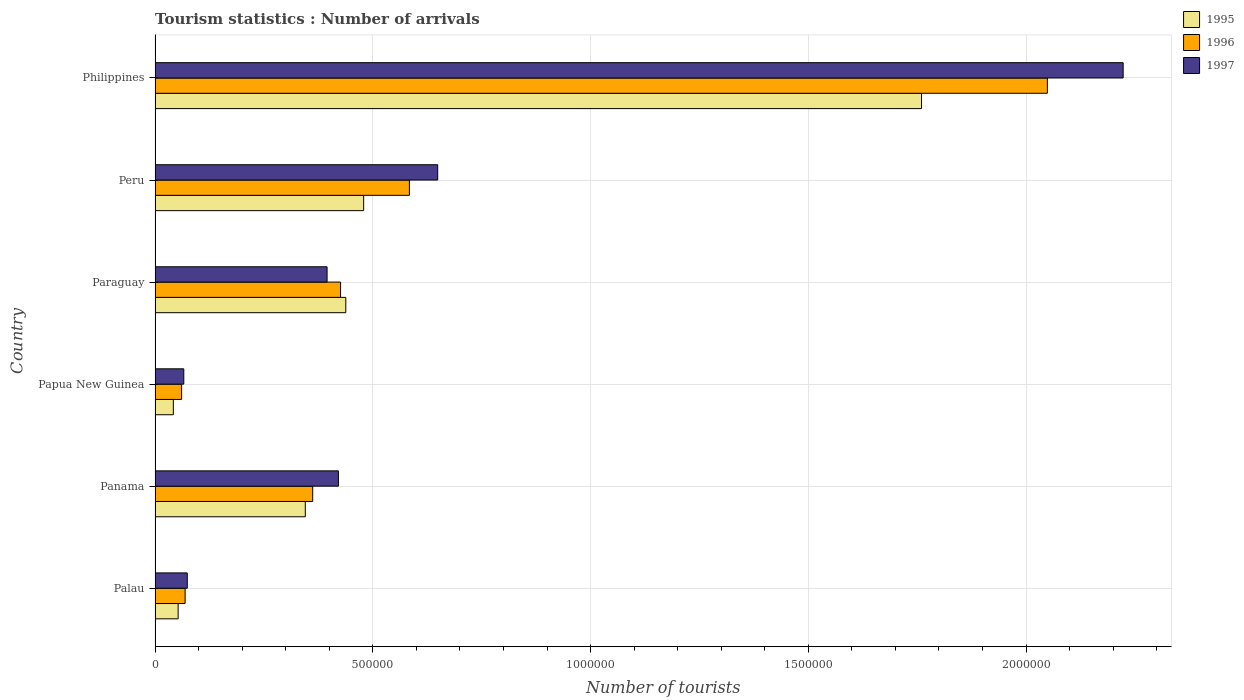How many different coloured bars are there?
Offer a terse response. 3. Are the number of bars per tick equal to the number of legend labels?
Provide a succinct answer. Yes. Are the number of bars on each tick of the Y-axis equal?
Your answer should be very brief. Yes. What is the label of the 3rd group of bars from the top?
Keep it short and to the point. Paraguay. What is the number of tourist arrivals in 1997 in Palau?
Provide a succinct answer. 7.40e+04. Across all countries, what is the maximum number of tourist arrivals in 1996?
Give a very brief answer. 2.05e+06. Across all countries, what is the minimum number of tourist arrivals in 1997?
Offer a very short reply. 6.60e+04. In which country was the number of tourist arrivals in 1997 maximum?
Your response must be concise. Philippines. In which country was the number of tourist arrivals in 1996 minimum?
Your answer should be very brief. Papua New Guinea. What is the total number of tourist arrivals in 1997 in the graph?
Make the answer very short. 3.83e+06. What is the difference between the number of tourist arrivals in 1995 in Peru and that in Philippines?
Give a very brief answer. -1.28e+06. What is the difference between the number of tourist arrivals in 1996 in Panama and the number of tourist arrivals in 1997 in Philippines?
Ensure brevity in your answer.  -1.86e+06. What is the average number of tourist arrivals in 1995 per country?
Provide a short and direct response. 5.20e+05. What is the difference between the number of tourist arrivals in 1997 and number of tourist arrivals in 1996 in Panama?
Provide a short and direct response. 5.90e+04. In how many countries, is the number of tourist arrivals in 1995 greater than 400000 ?
Give a very brief answer. 3. What is the ratio of the number of tourist arrivals in 1997 in Panama to that in Papua New Guinea?
Offer a terse response. 6.38. Is the number of tourist arrivals in 1996 in Palau less than that in Philippines?
Give a very brief answer. Yes. What is the difference between the highest and the second highest number of tourist arrivals in 1996?
Your response must be concise. 1.46e+06. What is the difference between the highest and the lowest number of tourist arrivals in 1995?
Make the answer very short. 1.72e+06. In how many countries, is the number of tourist arrivals in 1997 greater than the average number of tourist arrivals in 1997 taken over all countries?
Make the answer very short. 2. What does the 2nd bar from the bottom in Peru represents?
Your answer should be very brief. 1996. What is the difference between two consecutive major ticks on the X-axis?
Your answer should be very brief. 5.00e+05. Are the values on the major ticks of X-axis written in scientific E-notation?
Ensure brevity in your answer.  No. Does the graph contain grids?
Make the answer very short. Yes. What is the title of the graph?
Offer a terse response. Tourism statistics : Number of arrivals. Does "1996" appear as one of the legend labels in the graph?
Keep it short and to the point. Yes. What is the label or title of the X-axis?
Provide a succinct answer. Number of tourists. What is the Number of tourists of 1995 in Palau?
Keep it short and to the point. 5.30e+04. What is the Number of tourists in 1996 in Palau?
Provide a succinct answer. 6.90e+04. What is the Number of tourists of 1997 in Palau?
Your response must be concise. 7.40e+04. What is the Number of tourists of 1995 in Panama?
Provide a succinct answer. 3.45e+05. What is the Number of tourists of 1996 in Panama?
Provide a succinct answer. 3.62e+05. What is the Number of tourists of 1997 in Panama?
Give a very brief answer. 4.21e+05. What is the Number of tourists of 1995 in Papua New Guinea?
Your response must be concise. 4.20e+04. What is the Number of tourists of 1996 in Papua New Guinea?
Offer a very short reply. 6.10e+04. What is the Number of tourists in 1997 in Papua New Guinea?
Offer a very short reply. 6.60e+04. What is the Number of tourists in 1995 in Paraguay?
Provide a succinct answer. 4.38e+05. What is the Number of tourists of 1996 in Paraguay?
Your answer should be compact. 4.26e+05. What is the Number of tourists of 1997 in Paraguay?
Give a very brief answer. 3.95e+05. What is the Number of tourists of 1995 in Peru?
Give a very brief answer. 4.79e+05. What is the Number of tourists in 1996 in Peru?
Offer a terse response. 5.84e+05. What is the Number of tourists of 1997 in Peru?
Offer a very short reply. 6.49e+05. What is the Number of tourists in 1995 in Philippines?
Offer a very short reply. 1.76e+06. What is the Number of tourists of 1996 in Philippines?
Your answer should be very brief. 2.05e+06. What is the Number of tourists of 1997 in Philippines?
Your response must be concise. 2.22e+06. Across all countries, what is the maximum Number of tourists of 1995?
Make the answer very short. 1.76e+06. Across all countries, what is the maximum Number of tourists in 1996?
Your response must be concise. 2.05e+06. Across all countries, what is the maximum Number of tourists of 1997?
Offer a terse response. 2.22e+06. Across all countries, what is the minimum Number of tourists of 1995?
Keep it short and to the point. 4.20e+04. Across all countries, what is the minimum Number of tourists of 1996?
Ensure brevity in your answer.  6.10e+04. Across all countries, what is the minimum Number of tourists of 1997?
Your answer should be compact. 6.60e+04. What is the total Number of tourists of 1995 in the graph?
Give a very brief answer. 3.12e+06. What is the total Number of tourists of 1996 in the graph?
Your answer should be compact. 3.55e+06. What is the total Number of tourists in 1997 in the graph?
Offer a terse response. 3.83e+06. What is the difference between the Number of tourists in 1995 in Palau and that in Panama?
Offer a very short reply. -2.92e+05. What is the difference between the Number of tourists of 1996 in Palau and that in Panama?
Give a very brief answer. -2.93e+05. What is the difference between the Number of tourists of 1997 in Palau and that in Panama?
Provide a short and direct response. -3.47e+05. What is the difference between the Number of tourists in 1995 in Palau and that in Papua New Guinea?
Ensure brevity in your answer.  1.10e+04. What is the difference between the Number of tourists in 1996 in Palau and that in Papua New Guinea?
Ensure brevity in your answer.  8000. What is the difference between the Number of tourists in 1997 in Palau and that in Papua New Guinea?
Your answer should be very brief. 8000. What is the difference between the Number of tourists in 1995 in Palau and that in Paraguay?
Provide a succinct answer. -3.85e+05. What is the difference between the Number of tourists in 1996 in Palau and that in Paraguay?
Ensure brevity in your answer.  -3.57e+05. What is the difference between the Number of tourists in 1997 in Palau and that in Paraguay?
Your answer should be very brief. -3.21e+05. What is the difference between the Number of tourists in 1995 in Palau and that in Peru?
Keep it short and to the point. -4.26e+05. What is the difference between the Number of tourists of 1996 in Palau and that in Peru?
Your answer should be compact. -5.15e+05. What is the difference between the Number of tourists in 1997 in Palau and that in Peru?
Your answer should be compact. -5.75e+05. What is the difference between the Number of tourists of 1995 in Palau and that in Philippines?
Provide a succinct answer. -1.71e+06. What is the difference between the Number of tourists in 1996 in Palau and that in Philippines?
Ensure brevity in your answer.  -1.98e+06. What is the difference between the Number of tourists of 1997 in Palau and that in Philippines?
Ensure brevity in your answer.  -2.15e+06. What is the difference between the Number of tourists of 1995 in Panama and that in Papua New Guinea?
Offer a terse response. 3.03e+05. What is the difference between the Number of tourists of 1996 in Panama and that in Papua New Guinea?
Make the answer very short. 3.01e+05. What is the difference between the Number of tourists of 1997 in Panama and that in Papua New Guinea?
Make the answer very short. 3.55e+05. What is the difference between the Number of tourists of 1995 in Panama and that in Paraguay?
Make the answer very short. -9.30e+04. What is the difference between the Number of tourists of 1996 in Panama and that in Paraguay?
Provide a succinct answer. -6.40e+04. What is the difference between the Number of tourists of 1997 in Panama and that in Paraguay?
Provide a succinct answer. 2.60e+04. What is the difference between the Number of tourists in 1995 in Panama and that in Peru?
Your answer should be very brief. -1.34e+05. What is the difference between the Number of tourists in 1996 in Panama and that in Peru?
Your answer should be compact. -2.22e+05. What is the difference between the Number of tourists in 1997 in Panama and that in Peru?
Ensure brevity in your answer.  -2.28e+05. What is the difference between the Number of tourists of 1995 in Panama and that in Philippines?
Ensure brevity in your answer.  -1.42e+06. What is the difference between the Number of tourists in 1996 in Panama and that in Philippines?
Keep it short and to the point. -1.69e+06. What is the difference between the Number of tourists of 1997 in Panama and that in Philippines?
Your answer should be compact. -1.80e+06. What is the difference between the Number of tourists in 1995 in Papua New Guinea and that in Paraguay?
Keep it short and to the point. -3.96e+05. What is the difference between the Number of tourists of 1996 in Papua New Guinea and that in Paraguay?
Ensure brevity in your answer.  -3.65e+05. What is the difference between the Number of tourists of 1997 in Papua New Guinea and that in Paraguay?
Ensure brevity in your answer.  -3.29e+05. What is the difference between the Number of tourists in 1995 in Papua New Guinea and that in Peru?
Offer a very short reply. -4.37e+05. What is the difference between the Number of tourists of 1996 in Papua New Guinea and that in Peru?
Keep it short and to the point. -5.23e+05. What is the difference between the Number of tourists in 1997 in Papua New Guinea and that in Peru?
Your response must be concise. -5.83e+05. What is the difference between the Number of tourists of 1995 in Papua New Guinea and that in Philippines?
Your response must be concise. -1.72e+06. What is the difference between the Number of tourists of 1996 in Papua New Guinea and that in Philippines?
Offer a very short reply. -1.99e+06. What is the difference between the Number of tourists in 1997 in Papua New Guinea and that in Philippines?
Ensure brevity in your answer.  -2.16e+06. What is the difference between the Number of tourists in 1995 in Paraguay and that in Peru?
Give a very brief answer. -4.10e+04. What is the difference between the Number of tourists in 1996 in Paraguay and that in Peru?
Make the answer very short. -1.58e+05. What is the difference between the Number of tourists in 1997 in Paraguay and that in Peru?
Your answer should be compact. -2.54e+05. What is the difference between the Number of tourists of 1995 in Paraguay and that in Philippines?
Keep it short and to the point. -1.32e+06. What is the difference between the Number of tourists in 1996 in Paraguay and that in Philippines?
Keep it short and to the point. -1.62e+06. What is the difference between the Number of tourists in 1997 in Paraguay and that in Philippines?
Ensure brevity in your answer.  -1.83e+06. What is the difference between the Number of tourists of 1995 in Peru and that in Philippines?
Offer a terse response. -1.28e+06. What is the difference between the Number of tourists in 1996 in Peru and that in Philippines?
Your response must be concise. -1.46e+06. What is the difference between the Number of tourists of 1997 in Peru and that in Philippines?
Your answer should be compact. -1.57e+06. What is the difference between the Number of tourists in 1995 in Palau and the Number of tourists in 1996 in Panama?
Give a very brief answer. -3.09e+05. What is the difference between the Number of tourists of 1995 in Palau and the Number of tourists of 1997 in Panama?
Offer a terse response. -3.68e+05. What is the difference between the Number of tourists in 1996 in Palau and the Number of tourists in 1997 in Panama?
Ensure brevity in your answer.  -3.52e+05. What is the difference between the Number of tourists in 1995 in Palau and the Number of tourists in 1996 in Papua New Guinea?
Your response must be concise. -8000. What is the difference between the Number of tourists in 1995 in Palau and the Number of tourists in 1997 in Papua New Guinea?
Provide a succinct answer. -1.30e+04. What is the difference between the Number of tourists of 1996 in Palau and the Number of tourists of 1997 in Papua New Guinea?
Your response must be concise. 3000. What is the difference between the Number of tourists of 1995 in Palau and the Number of tourists of 1996 in Paraguay?
Offer a terse response. -3.73e+05. What is the difference between the Number of tourists of 1995 in Palau and the Number of tourists of 1997 in Paraguay?
Make the answer very short. -3.42e+05. What is the difference between the Number of tourists of 1996 in Palau and the Number of tourists of 1997 in Paraguay?
Your response must be concise. -3.26e+05. What is the difference between the Number of tourists in 1995 in Palau and the Number of tourists in 1996 in Peru?
Your answer should be very brief. -5.31e+05. What is the difference between the Number of tourists in 1995 in Palau and the Number of tourists in 1997 in Peru?
Provide a short and direct response. -5.96e+05. What is the difference between the Number of tourists in 1996 in Palau and the Number of tourists in 1997 in Peru?
Provide a succinct answer. -5.80e+05. What is the difference between the Number of tourists in 1995 in Palau and the Number of tourists in 1996 in Philippines?
Offer a very short reply. -2.00e+06. What is the difference between the Number of tourists in 1995 in Palau and the Number of tourists in 1997 in Philippines?
Provide a short and direct response. -2.17e+06. What is the difference between the Number of tourists in 1996 in Palau and the Number of tourists in 1997 in Philippines?
Make the answer very short. -2.15e+06. What is the difference between the Number of tourists of 1995 in Panama and the Number of tourists of 1996 in Papua New Guinea?
Provide a short and direct response. 2.84e+05. What is the difference between the Number of tourists in 1995 in Panama and the Number of tourists in 1997 in Papua New Guinea?
Give a very brief answer. 2.79e+05. What is the difference between the Number of tourists in 1996 in Panama and the Number of tourists in 1997 in Papua New Guinea?
Your answer should be compact. 2.96e+05. What is the difference between the Number of tourists in 1995 in Panama and the Number of tourists in 1996 in Paraguay?
Provide a succinct answer. -8.10e+04. What is the difference between the Number of tourists in 1996 in Panama and the Number of tourists in 1997 in Paraguay?
Your answer should be very brief. -3.30e+04. What is the difference between the Number of tourists in 1995 in Panama and the Number of tourists in 1996 in Peru?
Make the answer very short. -2.39e+05. What is the difference between the Number of tourists of 1995 in Panama and the Number of tourists of 1997 in Peru?
Provide a short and direct response. -3.04e+05. What is the difference between the Number of tourists of 1996 in Panama and the Number of tourists of 1997 in Peru?
Offer a very short reply. -2.87e+05. What is the difference between the Number of tourists of 1995 in Panama and the Number of tourists of 1996 in Philippines?
Keep it short and to the point. -1.70e+06. What is the difference between the Number of tourists in 1995 in Panama and the Number of tourists in 1997 in Philippines?
Your answer should be compact. -1.88e+06. What is the difference between the Number of tourists in 1996 in Panama and the Number of tourists in 1997 in Philippines?
Make the answer very short. -1.86e+06. What is the difference between the Number of tourists of 1995 in Papua New Guinea and the Number of tourists of 1996 in Paraguay?
Your answer should be very brief. -3.84e+05. What is the difference between the Number of tourists of 1995 in Papua New Guinea and the Number of tourists of 1997 in Paraguay?
Your answer should be very brief. -3.53e+05. What is the difference between the Number of tourists of 1996 in Papua New Guinea and the Number of tourists of 1997 in Paraguay?
Provide a short and direct response. -3.34e+05. What is the difference between the Number of tourists in 1995 in Papua New Guinea and the Number of tourists in 1996 in Peru?
Your response must be concise. -5.42e+05. What is the difference between the Number of tourists of 1995 in Papua New Guinea and the Number of tourists of 1997 in Peru?
Your answer should be compact. -6.07e+05. What is the difference between the Number of tourists of 1996 in Papua New Guinea and the Number of tourists of 1997 in Peru?
Give a very brief answer. -5.88e+05. What is the difference between the Number of tourists of 1995 in Papua New Guinea and the Number of tourists of 1996 in Philippines?
Keep it short and to the point. -2.01e+06. What is the difference between the Number of tourists in 1995 in Papua New Guinea and the Number of tourists in 1997 in Philippines?
Keep it short and to the point. -2.18e+06. What is the difference between the Number of tourists in 1996 in Papua New Guinea and the Number of tourists in 1997 in Philippines?
Keep it short and to the point. -2.16e+06. What is the difference between the Number of tourists in 1995 in Paraguay and the Number of tourists in 1996 in Peru?
Ensure brevity in your answer.  -1.46e+05. What is the difference between the Number of tourists of 1995 in Paraguay and the Number of tourists of 1997 in Peru?
Your answer should be very brief. -2.11e+05. What is the difference between the Number of tourists of 1996 in Paraguay and the Number of tourists of 1997 in Peru?
Keep it short and to the point. -2.23e+05. What is the difference between the Number of tourists of 1995 in Paraguay and the Number of tourists of 1996 in Philippines?
Give a very brief answer. -1.61e+06. What is the difference between the Number of tourists of 1995 in Paraguay and the Number of tourists of 1997 in Philippines?
Your response must be concise. -1.78e+06. What is the difference between the Number of tourists of 1996 in Paraguay and the Number of tourists of 1997 in Philippines?
Provide a succinct answer. -1.80e+06. What is the difference between the Number of tourists in 1995 in Peru and the Number of tourists in 1996 in Philippines?
Keep it short and to the point. -1.57e+06. What is the difference between the Number of tourists of 1995 in Peru and the Number of tourists of 1997 in Philippines?
Your answer should be very brief. -1.74e+06. What is the difference between the Number of tourists of 1996 in Peru and the Number of tourists of 1997 in Philippines?
Keep it short and to the point. -1.64e+06. What is the average Number of tourists in 1995 per country?
Offer a very short reply. 5.20e+05. What is the average Number of tourists of 1996 per country?
Provide a short and direct response. 5.92e+05. What is the average Number of tourists of 1997 per country?
Give a very brief answer. 6.38e+05. What is the difference between the Number of tourists of 1995 and Number of tourists of 1996 in Palau?
Your answer should be very brief. -1.60e+04. What is the difference between the Number of tourists in 1995 and Number of tourists in 1997 in Palau?
Give a very brief answer. -2.10e+04. What is the difference between the Number of tourists in 1996 and Number of tourists in 1997 in Palau?
Your answer should be compact. -5000. What is the difference between the Number of tourists of 1995 and Number of tourists of 1996 in Panama?
Your answer should be very brief. -1.70e+04. What is the difference between the Number of tourists in 1995 and Number of tourists in 1997 in Panama?
Keep it short and to the point. -7.60e+04. What is the difference between the Number of tourists of 1996 and Number of tourists of 1997 in Panama?
Make the answer very short. -5.90e+04. What is the difference between the Number of tourists of 1995 and Number of tourists of 1996 in Papua New Guinea?
Provide a succinct answer. -1.90e+04. What is the difference between the Number of tourists in 1995 and Number of tourists in 1997 in Papua New Guinea?
Ensure brevity in your answer.  -2.40e+04. What is the difference between the Number of tourists in 1996 and Number of tourists in 1997 in Papua New Guinea?
Give a very brief answer. -5000. What is the difference between the Number of tourists in 1995 and Number of tourists in 1996 in Paraguay?
Offer a very short reply. 1.20e+04. What is the difference between the Number of tourists of 1995 and Number of tourists of 1997 in Paraguay?
Give a very brief answer. 4.30e+04. What is the difference between the Number of tourists in 1996 and Number of tourists in 1997 in Paraguay?
Provide a short and direct response. 3.10e+04. What is the difference between the Number of tourists of 1995 and Number of tourists of 1996 in Peru?
Your answer should be very brief. -1.05e+05. What is the difference between the Number of tourists in 1996 and Number of tourists in 1997 in Peru?
Keep it short and to the point. -6.50e+04. What is the difference between the Number of tourists in 1995 and Number of tourists in 1996 in Philippines?
Your answer should be compact. -2.89e+05. What is the difference between the Number of tourists of 1995 and Number of tourists of 1997 in Philippines?
Offer a very short reply. -4.63e+05. What is the difference between the Number of tourists in 1996 and Number of tourists in 1997 in Philippines?
Make the answer very short. -1.74e+05. What is the ratio of the Number of tourists in 1995 in Palau to that in Panama?
Provide a succinct answer. 0.15. What is the ratio of the Number of tourists of 1996 in Palau to that in Panama?
Your response must be concise. 0.19. What is the ratio of the Number of tourists of 1997 in Palau to that in Panama?
Your response must be concise. 0.18. What is the ratio of the Number of tourists of 1995 in Palau to that in Papua New Guinea?
Make the answer very short. 1.26. What is the ratio of the Number of tourists of 1996 in Palau to that in Papua New Guinea?
Make the answer very short. 1.13. What is the ratio of the Number of tourists in 1997 in Palau to that in Papua New Guinea?
Offer a very short reply. 1.12. What is the ratio of the Number of tourists of 1995 in Palau to that in Paraguay?
Your answer should be compact. 0.12. What is the ratio of the Number of tourists of 1996 in Palau to that in Paraguay?
Your answer should be compact. 0.16. What is the ratio of the Number of tourists of 1997 in Palau to that in Paraguay?
Offer a terse response. 0.19. What is the ratio of the Number of tourists of 1995 in Palau to that in Peru?
Offer a terse response. 0.11. What is the ratio of the Number of tourists of 1996 in Palau to that in Peru?
Your response must be concise. 0.12. What is the ratio of the Number of tourists in 1997 in Palau to that in Peru?
Provide a succinct answer. 0.11. What is the ratio of the Number of tourists of 1995 in Palau to that in Philippines?
Offer a terse response. 0.03. What is the ratio of the Number of tourists in 1996 in Palau to that in Philippines?
Keep it short and to the point. 0.03. What is the ratio of the Number of tourists of 1997 in Palau to that in Philippines?
Give a very brief answer. 0.03. What is the ratio of the Number of tourists in 1995 in Panama to that in Papua New Guinea?
Your answer should be compact. 8.21. What is the ratio of the Number of tourists in 1996 in Panama to that in Papua New Guinea?
Give a very brief answer. 5.93. What is the ratio of the Number of tourists in 1997 in Panama to that in Papua New Guinea?
Provide a short and direct response. 6.38. What is the ratio of the Number of tourists in 1995 in Panama to that in Paraguay?
Give a very brief answer. 0.79. What is the ratio of the Number of tourists of 1996 in Panama to that in Paraguay?
Provide a succinct answer. 0.85. What is the ratio of the Number of tourists of 1997 in Panama to that in Paraguay?
Your response must be concise. 1.07. What is the ratio of the Number of tourists in 1995 in Panama to that in Peru?
Your response must be concise. 0.72. What is the ratio of the Number of tourists of 1996 in Panama to that in Peru?
Your answer should be compact. 0.62. What is the ratio of the Number of tourists in 1997 in Panama to that in Peru?
Provide a short and direct response. 0.65. What is the ratio of the Number of tourists in 1995 in Panama to that in Philippines?
Keep it short and to the point. 0.2. What is the ratio of the Number of tourists of 1996 in Panama to that in Philippines?
Offer a terse response. 0.18. What is the ratio of the Number of tourists of 1997 in Panama to that in Philippines?
Keep it short and to the point. 0.19. What is the ratio of the Number of tourists of 1995 in Papua New Guinea to that in Paraguay?
Offer a terse response. 0.1. What is the ratio of the Number of tourists of 1996 in Papua New Guinea to that in Paraguay?
Offer a very short reply. 0.14. What is the ratio of the Number of tourists in 1997 in Papua New Guinea to that in Paraguay?
Your answer should be compact. 0.17. What is the ratio of the Number of tourists of 1995 in Papua New Guinea to that in Peru?
Offer a very short reply. 0.09. What is the ratio of the Number of tourists in 1996 in Papua New Guinea to that in Peru?
Keep it short and to the point. 0.1. What is the ratio of the Number of tourists in 1997 in Papua New Guinea to that in Peru?
Ensure brevity in your answer.  0.1. What is the ratio of the Number of tourists in 1995 in Papua New Guinea to that in Philippines?
Provide a short and direct response. 0.02. What is the ratio of the Number of tourists in 1996 in Papua New Guinea to that in Philippines?
Offer a very short reply. 0.03. What is the ratio of the Number of tourists of 1997 in Papua New Guinea to that in Philippines?
Provide a short and direct response. 0.03. What is the ratio of the Number of tourists in 1995 in Paraguay to that in Peru?
Your response must be concise. 0.91. What is the ratio of the Number of tourists in 1996 in Paraguay to that in Peru?
Provide a succinct answer. 0.73. What is the ratio of the Number of tourists in 1997 in Paraguay to that in Peru?
Keep it short and to the point. 0.61. What is the ratio of the Number of tourists of 1995 in Paraguay to that in Philippines?
Offer a very short reply. 0.25. What is the ratio of the Number of tourists in 1996 in Paraguay to that in Philippines?
Ensure brevity in your answer.  0.21. What is the ratio of the Number of tourists in 1997 in Paraguay to that in Philippines?
Your answer should be very brief. 0.18. What is the ratio of the Number of tourists in 1995 in Peru to that in Philippines?
Give a very brief answer. 0.27. What is the ratio of the Number of tourists in 1996 in Peru to that in Philippines?
Offer a very short reply. 0.28. What is the ratio of the Number of tourists of 1997 in Peru to that in Philippines?
Your answer should be compact. 0.29. What is the difference between the highest and the second highest Number of tourists in 1995?
Give a very brief answer. 1.28e+06. What is the difference between the highest and the second highest Number of tourists of 1996?
Your answer should be compact. 1.46e+06. What is the difference between the highest and the second highest Number of tourists of 1997?
Ensure brevity in your answer.  1.57e+06. What is the difference between the highest and the lowest Number of tourists in 1995?
Give a very brief answer. 1.72e+06. What is the difference between the highest and the lowest Number of tourists in 1996?
Offer a terse response. 1.99e+06. What is the difference between the highest and the lowest Number of tourists in 1997?
Provide a short and direct response. 2.16e+06. 